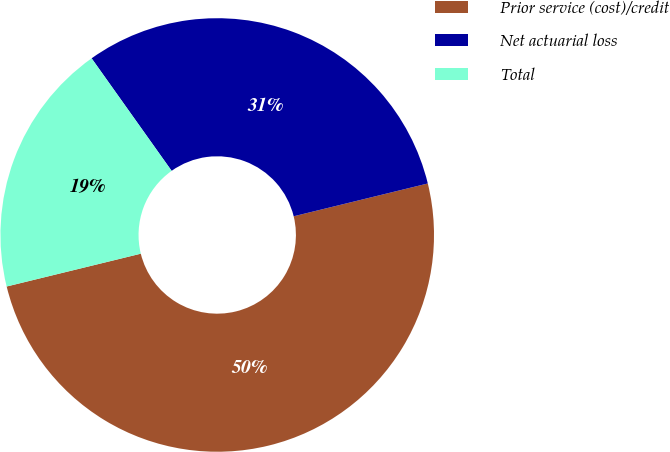Convert chart to OTSL. <chart><loc_0><loc_0><loc_500><loc_500><pie_chart><fcel>Prior service (cost)/credit<fcel>Net actuarial loss<fcel>Total<nl><fcel>50.0%<fcel>31.02%<fcel>18.98%<nl></chart> 